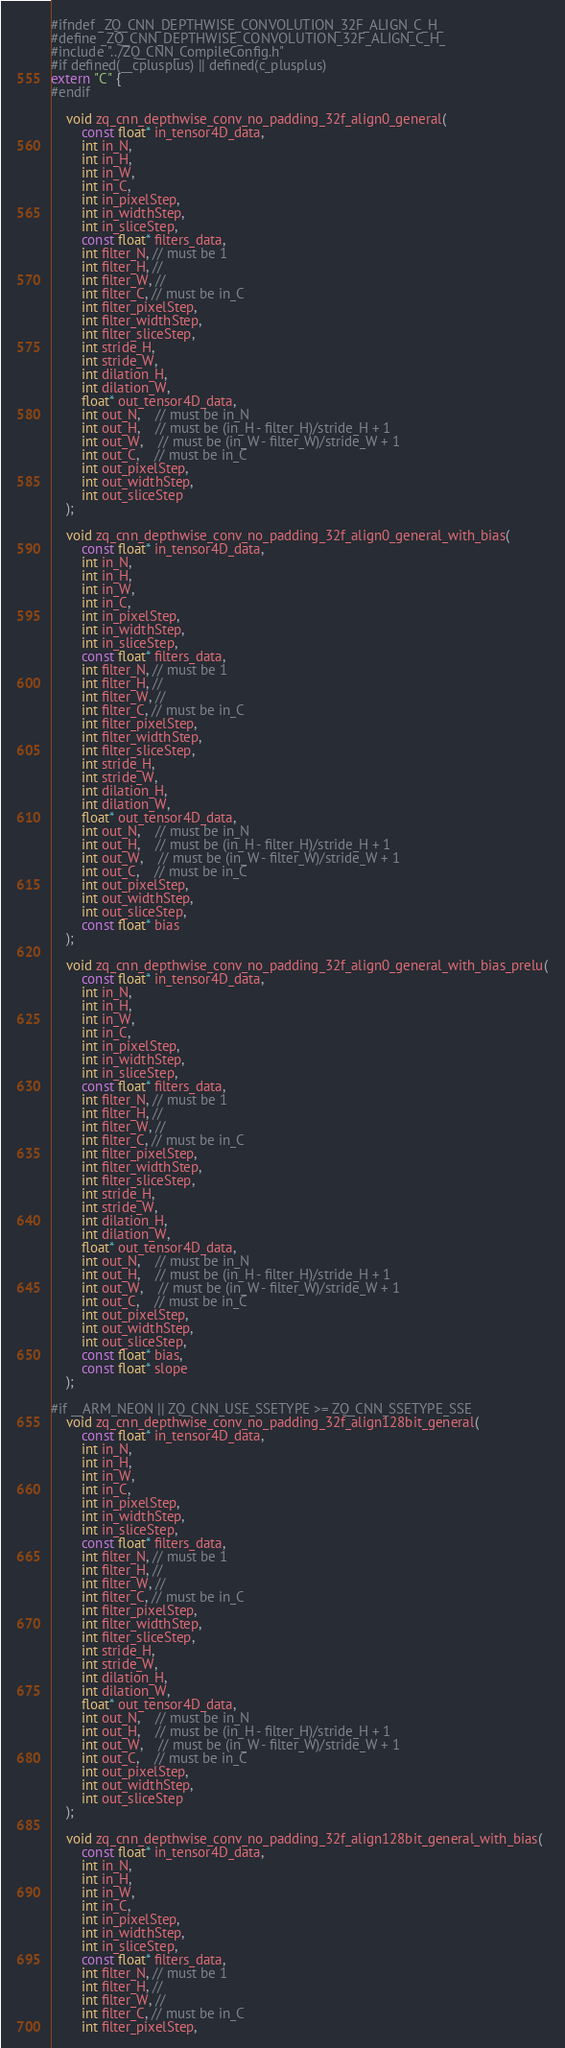<code> <loc_0><loc_0><loc_500><loc_500><_C_>#ifndef _ZQ_CNN_DEPTHWISE_CONVOLUTION_32F_ALIGN_C_H_
#define _ZQ_CNN_DEPTHWISE_CONVOLUTION_32F_ALIGN_C_H_
#include "../ZQ_CNN_CompileConfig.h"
#if defined(__cplusplus) || defined(c_plusplus) 
extern "C" {
#endif

	void zq_cnn_depthwise_conv_no_padding_32f_align0_general(
		const float* in_tensor4D_data,
		int in_N,
		int in_H,
		int in_W,
		int in_C,
		int in_pixelStep,
		int in_widthStep,
		int in_sliceStep,
		const float* filters_data,
		int filter_N, // must be 1
		int filter_H, // 
		int filter_W, // 
		int filter_C, // must be in_C
		int filter_pixelStep,
		int filter_widthStep,
		int filter_sliceStep,
		int stride_H,
		int stride_W,
		int dilation_H,
		int dilation_W,
		float* out_tensor4D_data,
		int out_N,	// must be in_N
		int out_H,	// must be (in_H - filter_H)/stride_H + 1
		int out_W,	// must be (in_W - filter_W)/stride_W + 1
		int out_C,	// must be in_C
		int out_pixelStep,
		int out_widthStep,
		int out_sliceStep
	);

	void zq_cnn_depthwise_conv_no_padding_32f_align0_general_with_bias(
		const float* in_tensor4D_data,
		int in_N,
		int in_H,
		int in_W,
		int in_C,
		int in_pixelStep,
		int in_widthStep,
		int in_sliceStep,
		const float* filters_data,
		int filter_N, // must be 1
		int filter_H, // 
		int filter_W, // 
		int filter_C, // must be in_C
		int filter_pixelStep,
		int filter_widthStep,
		int filter_sliceStep,
		int stride_H,
		int stride_W,
		int dilation_H,
		int dilation_W,
		float* out_tensor4D_data,
		int out_N,	// must be in_N
		int out_H,	// must be (in_H - filter_H)/stride_H + 1
		int out_W,	// must be (in_W - filter_W)/stride_W + 1
		int out_C,	// must be in_C
		int out_pixelStep,
		int out_widthStep,
		int out_sliceStep,
		const float* bias
	);

	void zq_cnn_depthwise_conv_no_padding_32f_align0_general_with_bias_prelu(
		const float* in_tensor4D_data,
		int in_N,
		int in_H,
		int in_W,
		int in_C,
		int in_pixelStep,
		int in_widthStep,
		int in_sliceStep,
		const float* filters_data,
		int filter_N, // must be 1
		int filter_H, // 
		int filter_W, // 
		int filter_C, // must be in_C
		int filter_pixelStep,
		int filter_widthStep,
		int filter_sliceStep,
		int stride_H,
		int stride_W,
		int dilation_H,
		int dilation_W,
		float* out_tensor4D_data,
		int out_N,	// must be in_N
		int out_H,	// must be (in_H - filter_H)/stride_H + 1
		int out_W,	// must be (in_W - filter_W)/stride_W + 1
		int out_C,	// must be in_C
		int out_pixelStep,
		int out_widthStep,
		int out_sliceStep,
		const float* bias,
		const float* slope
	);

#if __ARM_NEON || ZQ_CNN_USE_SSETYPE >= ZQ_CNN_SSETYPE_SSE
	void zq_cnn_depthwise_conv_no_padding_32f_align128bit_general(
		const float* in_tensor4D_data,
		int in_N,
		int in_H,
		int in_W,
		int in_C,
		int in_pixelStep,
		int in_widthStep,
		int in_sliceStep,
		const float* filters_data,
		int filter_N, // must be 1
		int filter_H, // 
		int filter_W, // 
		int filter_C, // must be in_C
		int filter_pixelStep,
		int filter_widthStep,
		int filter_sliceStep,
		int stride_H,
		int stride_W,
		int dilation_H,
		int dilation_W,
		float* out_tensor4D_data,
		int out_N,	// must be in_N
		int out_H,	// must be (in_H - filter_H)/stride_H + 1
		int out_W,	// must be (in_W - filter_W)/stride_W + 1
		int out_C,	// must be in_C
		int out_pixelStep,
		int out_widthStep,
		int out_sliceStep
	);

	void zq_cnn_depthwise_conv_no_padding_32f_align128bit_general_with_bias(
		const float* in_tensor4D_data,
		int in_N,
		int in_H,
		int in_W,
		int in_C,
		int in_pixelStep,
		int in_widthStep,
		int in_sliceStep,
		const float* filters_data,
		int filter_N, // must be 1
		int filter_H, // 
		int filter_W, // 
		int filter_C, // must be in_C
		int filter_pixelStep,</code> 